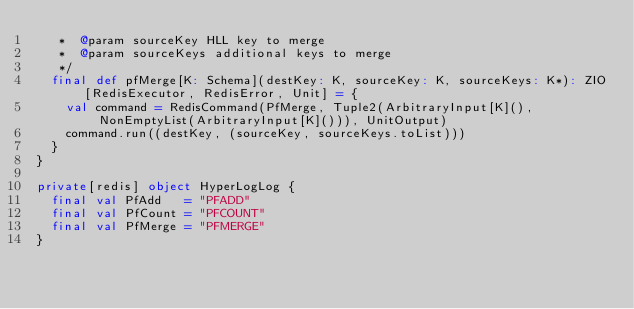<code> <loc_0><loc_0><loc_500><loc_500><_Scala_>   *  @param sourceKey HLL key to merge
   *  @param sourceKeys additional keys to merge
   */
  final def pfMerge[K: Schema](destKey: K, sourceKey: K, sourceKeys: K*): ZIO[RedisExecutor, RedisError, Unit] = {
    val command = RedisCommand(PfMerge, Tuple2(ArbitraryInput[K](), NonEmptyList(ArbitraryInput[K]())), UnitOutput)
    command.run((destKey, (sourceKey, sourceKeys.toList)))
  }
}

private[redis] object HyperLogLog {
  final val PfAdd   = "PFADD"
  final val PfCount = "PFCOUNT"
  final val PfMerge = "PFMERGE"
}
</code> 